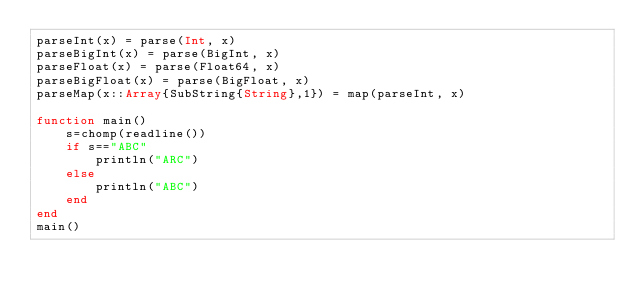Convert code to text. <code><loc_0><loc_0><loc_500><loc_500><_Julia_>parseInt(x) = parse(Int, x)
parseBigInt(x) = parse(BigInt, x)
parseFloat(x) = parse(Float64, x)
parseBigFloat(x) = parse(BigFloat, x)
parseMap(x::Array{SubString{String},1}) = map(parseInt, x)

function main()
    s=chomp(readline())
    if s=="ABC"
        println("ARC")
    else
        println("ABC")
    end
end
main()</code> 